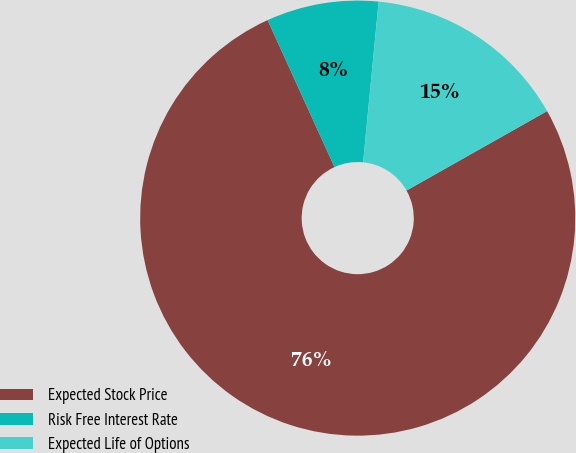Convert chart to OTSL. <chart><loc_0><loc_0><loc_500><loc_500><pie_chart><fcel>Expected Stock Price<fcel>Risk Free Interest Rate<fcel>Expected Life of Options<nl><fcel>76.39%<fcel>8.33%<fcel>15.28%<nl></chart> 